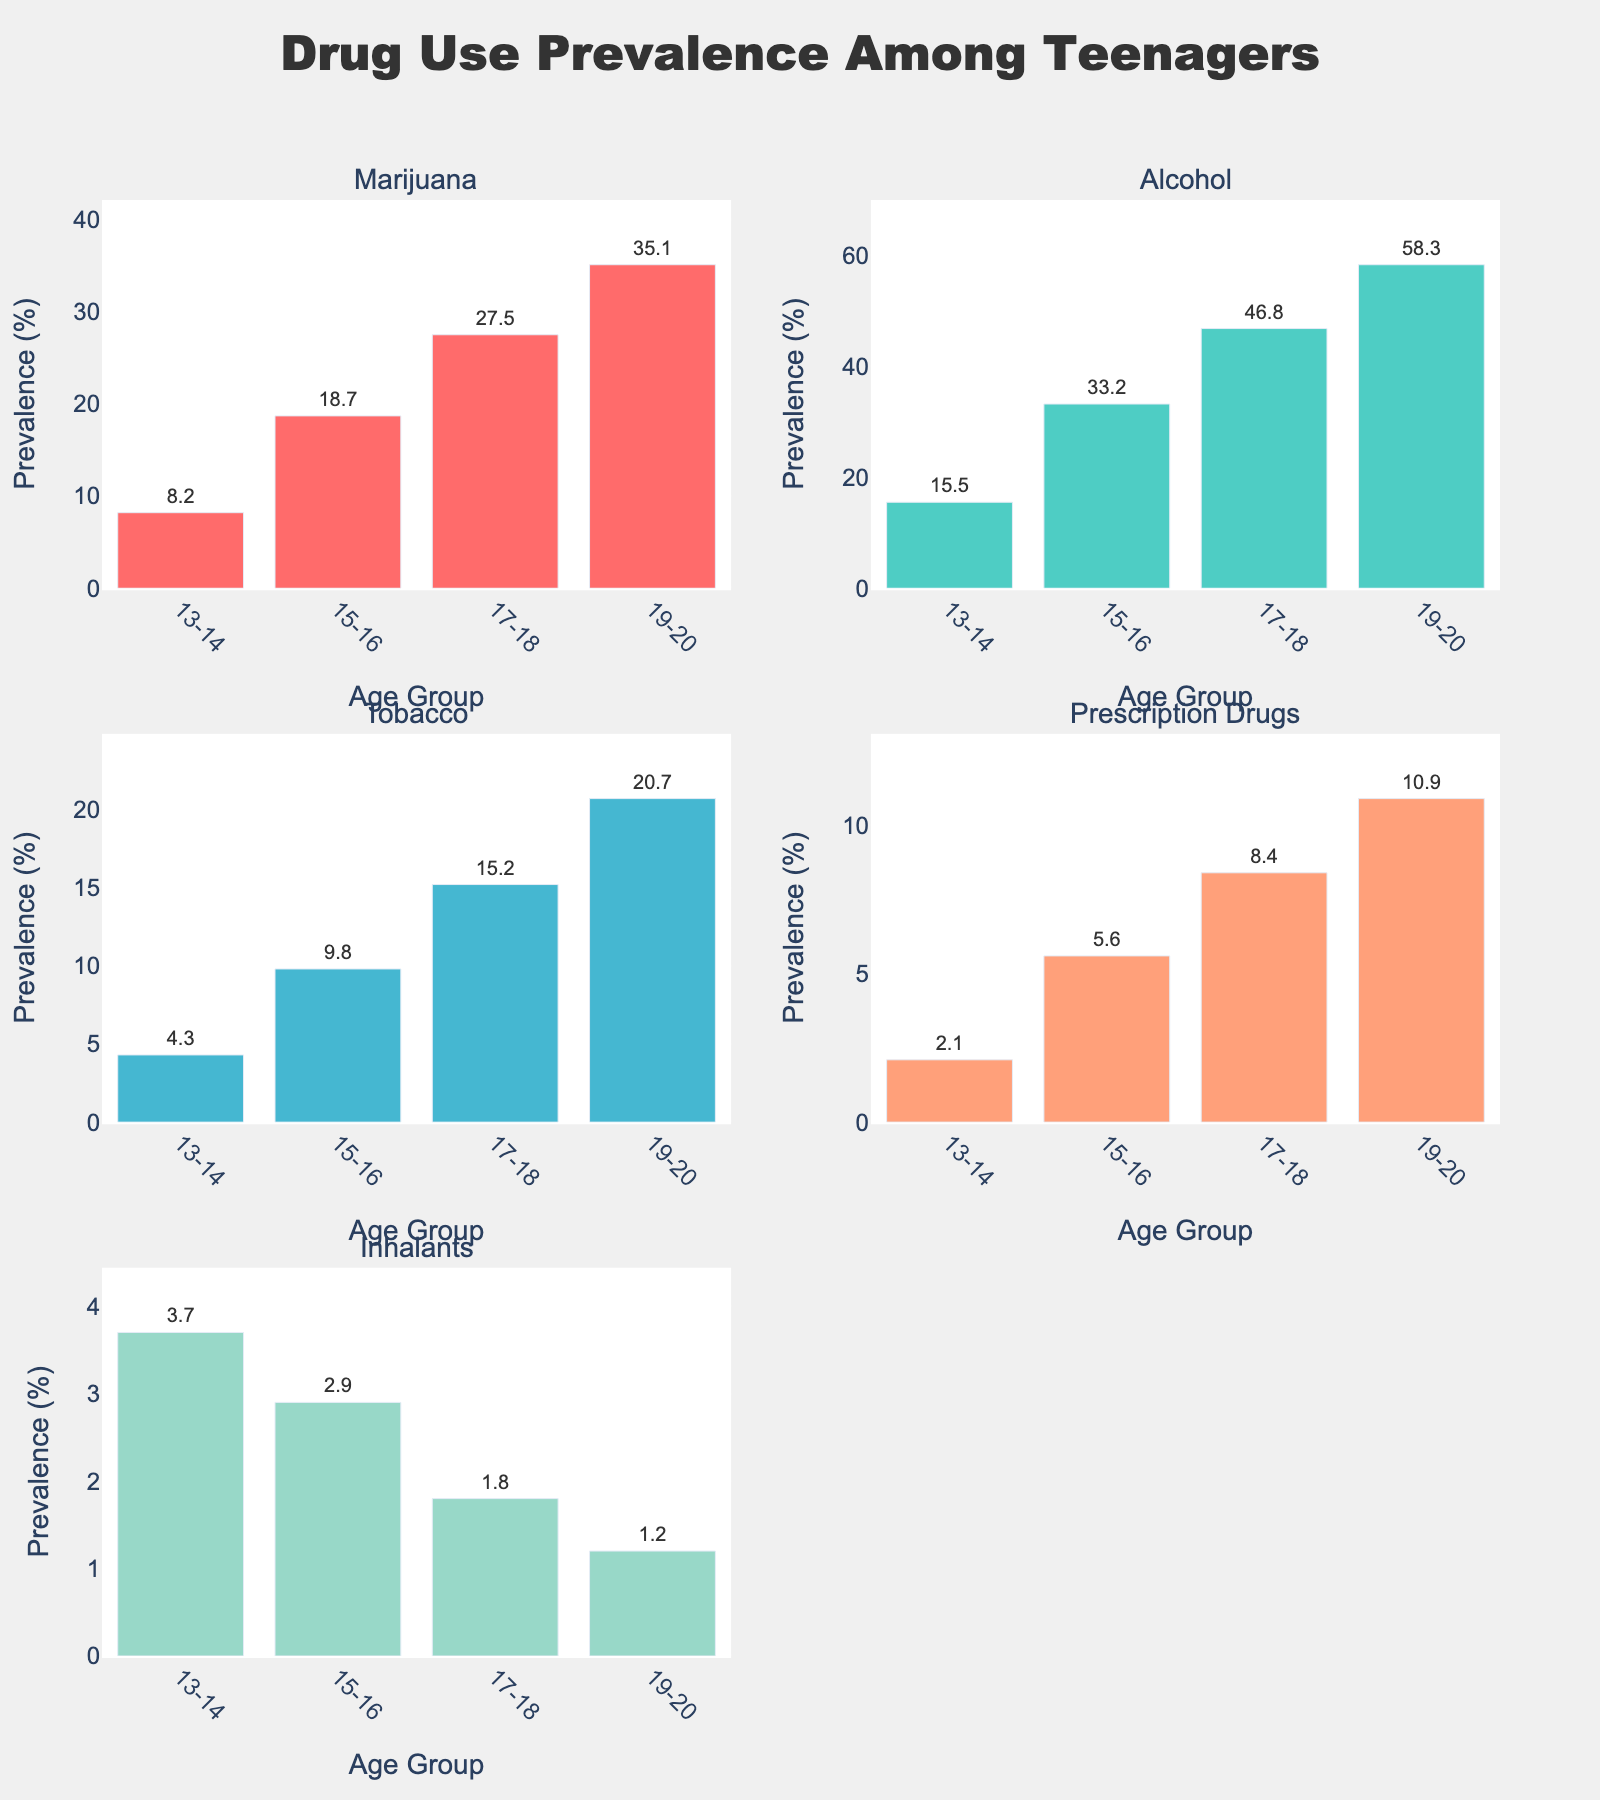What's the title of the figure? The title is usually found at the top of the figure. It provides a summary of what data is being presented in the figure.
Answer: Drug Use Prevalence Among Teenagers What age group has the highest prevalence of Alcohol use? Look at the Alcohol subplot and identify the age group with the tallest bar.
Answer: 19-20 How does the prevalence of Marijuana use change from the 13-14 age group to the 17-18 age group? Compare the heights of the Marijuana bars for the 13-14 and 17-18 age groups to see the difference in percentage.
Answer: It increases from 8.2% to 27.5% Which substance has the lowest prevalence among 17-18 year-olds? Look at the 17-18 bars in each subplot and find the shortest one.
Answer: Inhalants What is the average prevalence of Tobacco use across all age groups? Add up the prevalence values for Tobacco across all age groups and divide by the number of age groups (4). Calculation: (4.3 + 9.8 + 15.2 + 20.7) / 4.
Answer: 12.5% Which substance shows a decreasing trend as the age group progresses? Check the subplots and look for a substance where the bar heights decrease from left to right age groups.
Answer: Inhalants By how much does Alcohol use increase from the 15-16 age group to the 19-20 age group? Subtract the prevalence of Alcohol in the 15-16 age group from the prevalence in the 19-20 age group. Calculation: 58.3 - 33.2.
Answer: 25.1% Among the substances shown, which one has the most significant increase in prevalence between the smallest and largest age groups? Calculate the difference between the prevalence values of the youngest and oldest groups for each substance and find the greatest increase. Marijuana has the biggest increase: 35.1% - 8.2%.
Answer: Marijuana 